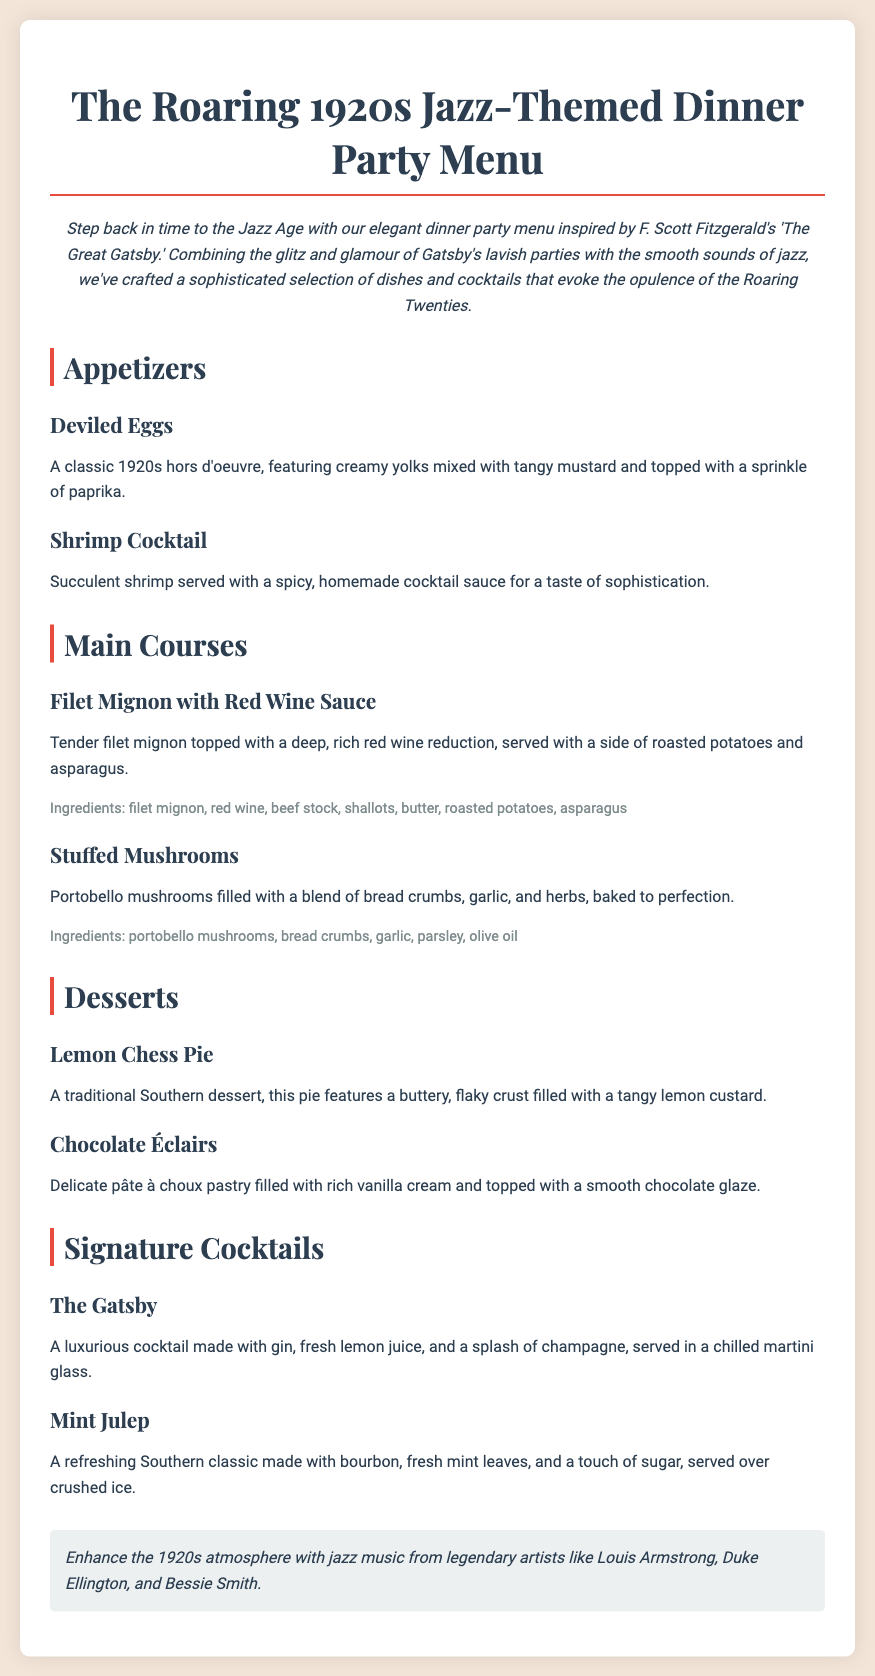What is the theme of the dinner party? The introduction highlights that the dinner party is inspired by F. Scott Fitzgerald's 'The Great Gatsby' and the Jazz Age.
Answer: Jazz-Themed How many appetizers are listed in the menu? The menu section for appetizers lists two items: Deviled Eggs and Shrimp Cocktail.
Answer: 2 What is the main ingredient in the Filet Mignon dish? The description for Filet Mignon mentions filet mignon as the main ingredient.
Answer: Filet mignon Which cocktail is described as a Southern classic? The signature cocktails section describes Mint Julep as a Southern classic.
Answer: Mint Julep What dessert features a buttery, flaky crust? The description for Lemon Chess Pie mentions it has a buttery, flaky crust.
Answer: Lemon Chess Pie What is the main alcoholic ingredient in The Gatsby cocktail? The cocktail description states that gin is the main alcoholic ingredient in The Gatsby.
Answer: Gin What type of music is suggested to enhance the atmosphere? The note at the bottom of the document suggests jazz music from legendary artists.
Answer: Jazz music What type of pie is featured in the dessert section? The menu lists Lemon Chess Pie, which is a type of pie in the dessert section.
Answer: Chess Pie 